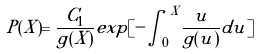Convert formula to latex. <formula><loc_0><loc_0><loc_500><loc_500>P ( X ) = \frac { C _ { 1 } } { g ( X ) } e x p [ - { \int _ { 0 } } ^ { X } \frac { u } { g ( u ) } d u ]</formula> 